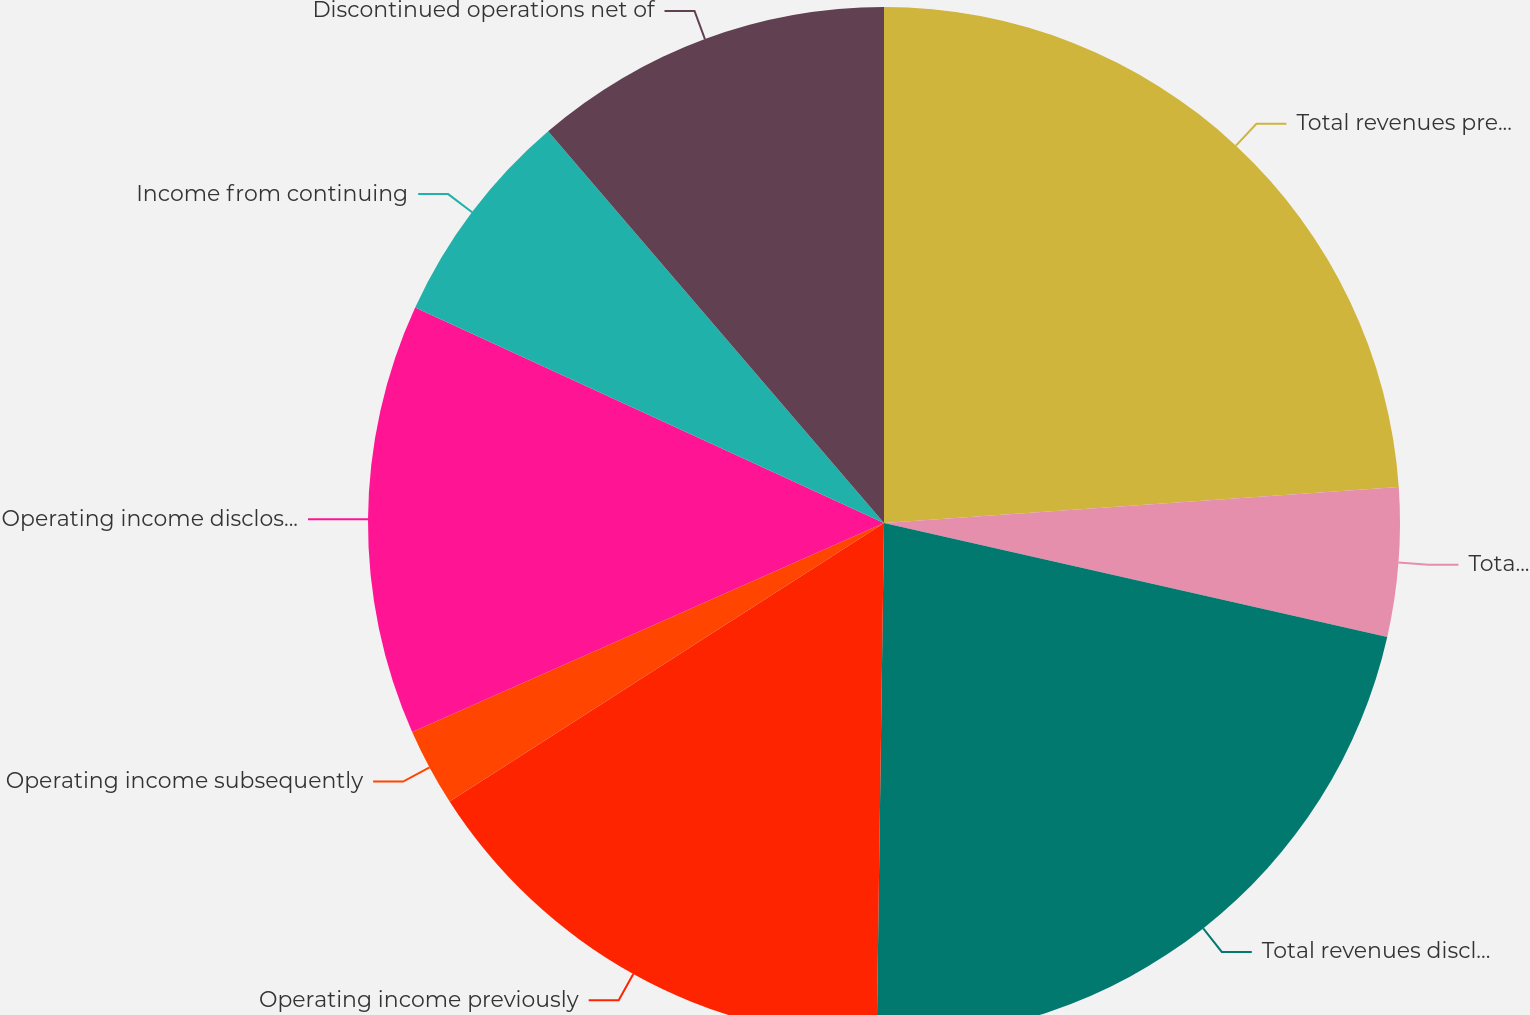Convert chart. <chart><loc_0><loc_0><loc_500><loc_500><pie_chart><fcel>Total revenues previously<fcel>Total revenues subsequently<fcel>Total revenues disclosed in<fcel>Operating income previously<fcel>Operating income subsequently<fcel>Operating income disclosed in<fcel>Income from continuing<fcel>Discontinued operations net of<nl><fcel>23.89%<fcel>4.65%<fcel>21.68%<fcel>15.7%<fcel>2.44%<fcel>13.49%<fcel>6.86%<fcel>11.28%<nl></chart> 